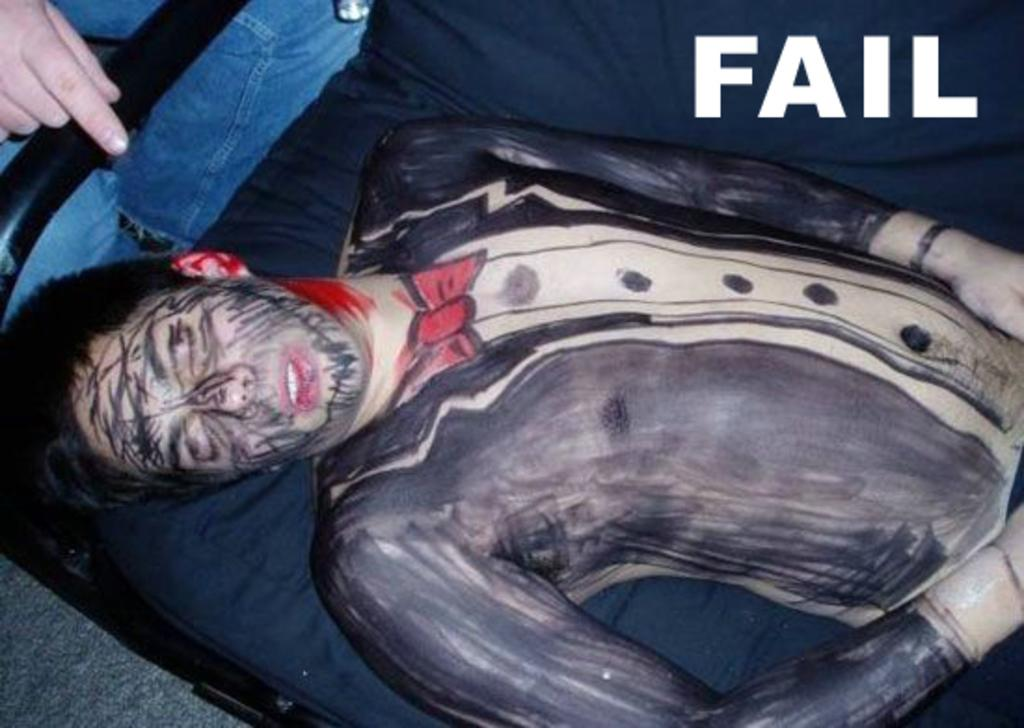What is the person in the image doing? The person is lying on an object in the image. What type of material can be seen in the image? Metal rods are visible in the image. What else is present in the image besides the person and metal rods? There is text in the image. Can you tell if there is another person in the image? There may be a person standing in the image. What can be inferred about the time of day when the image was taken? The image was likely taken during the day. What type of beetle can be seen crawling on the person in the image? There is no beetle present in the image; the person is lying on an object, and no insects are visible. 